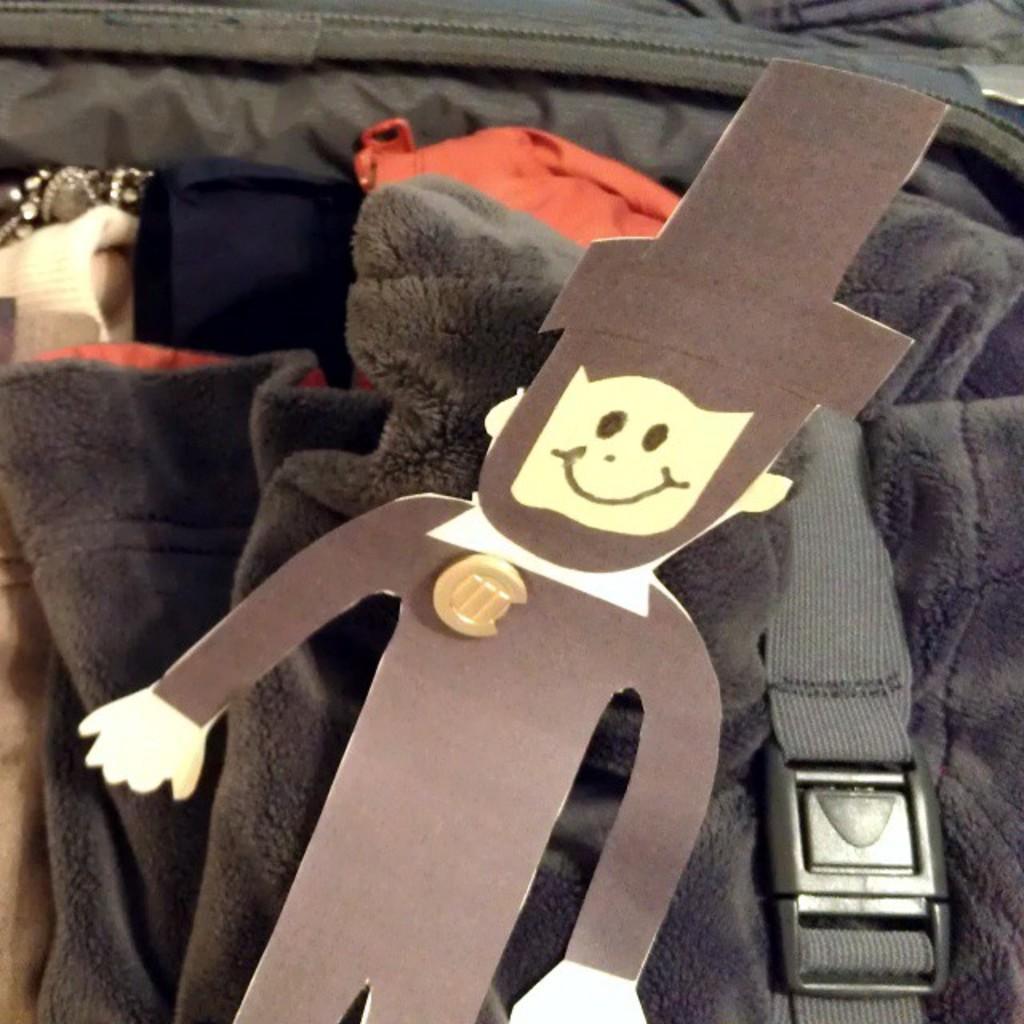In one or two sentences, can you explain what this image depicts? In this picture I can see there is a paper cutting of a man and there are few sweaters and dresses packed in a suit case and there is a seat belt attached to them in the luggage. 